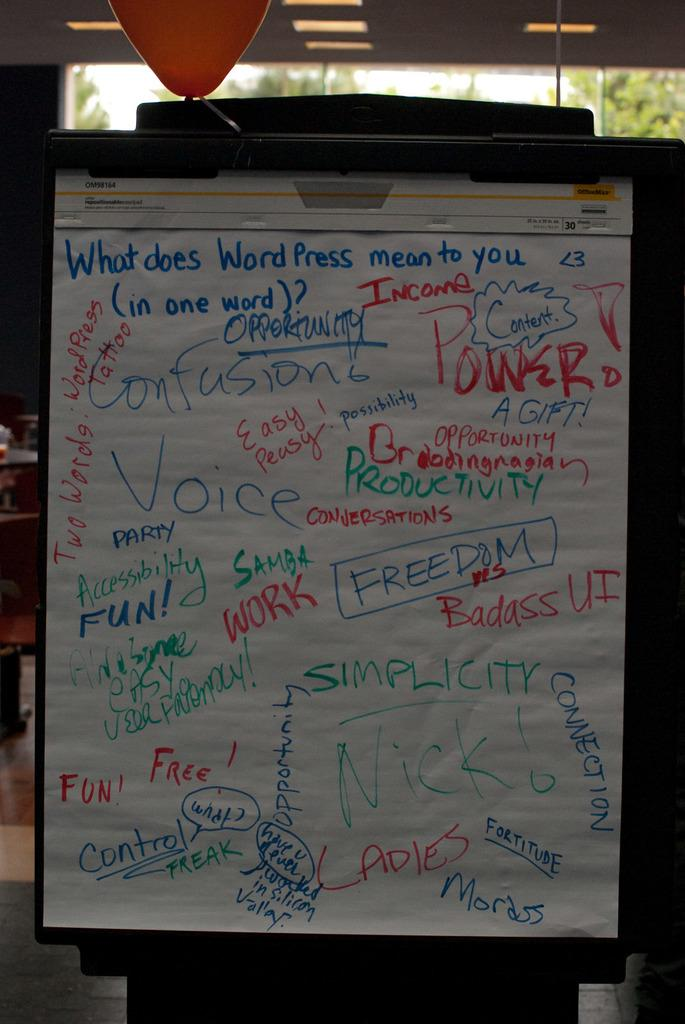<image>
Present a compact description of the photo's key features. A piece of chart paper with the title What does Word Press mean to you. 